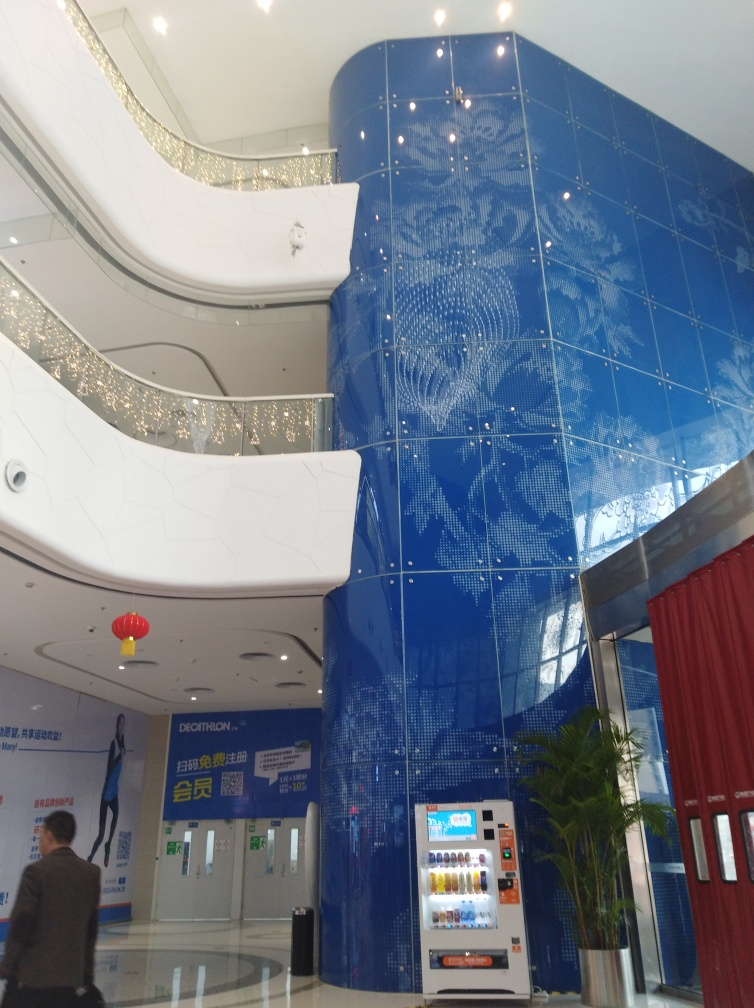Is the architectural style the main subject in the image? Indeed, the architectural style is prominently featured and is a central aspect of the image, showcasing a modern design with a dynamic blue color scheme and intricate pattern details. The curvature of the walls and the strategic lighting add to the visual impact of the style, making it the focal point in this setting. 